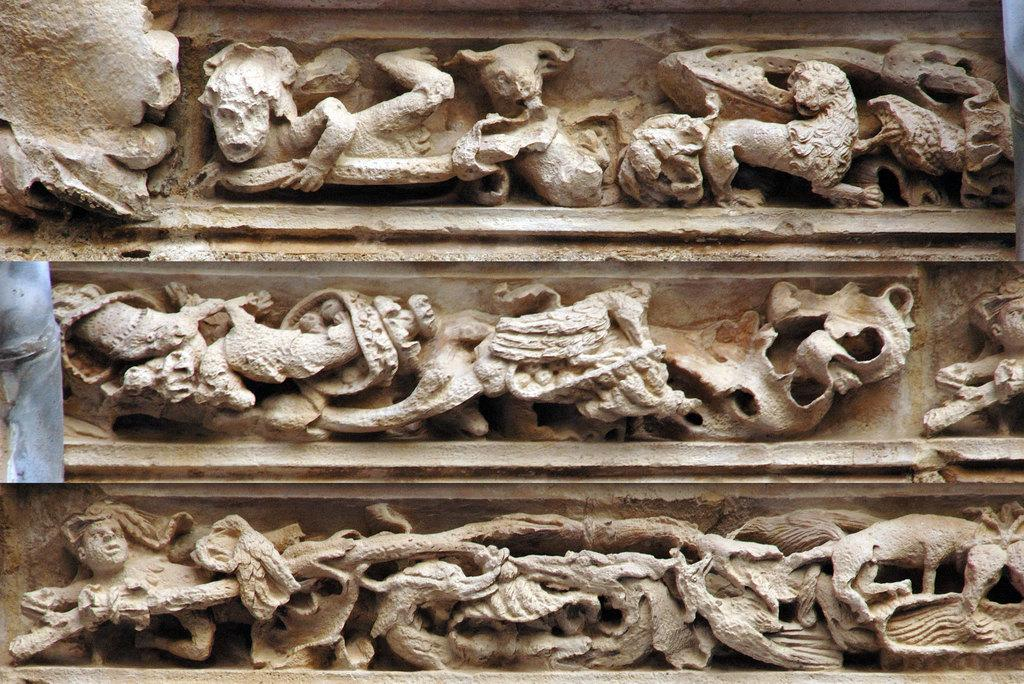What is depicted on the wall in the image? There are sculptures on a wall in the image. How many lizards are crawling on the farmer's bed in the image? There are no lizards, farmers, or beds present in the image; it only features sculptures on a wall. 